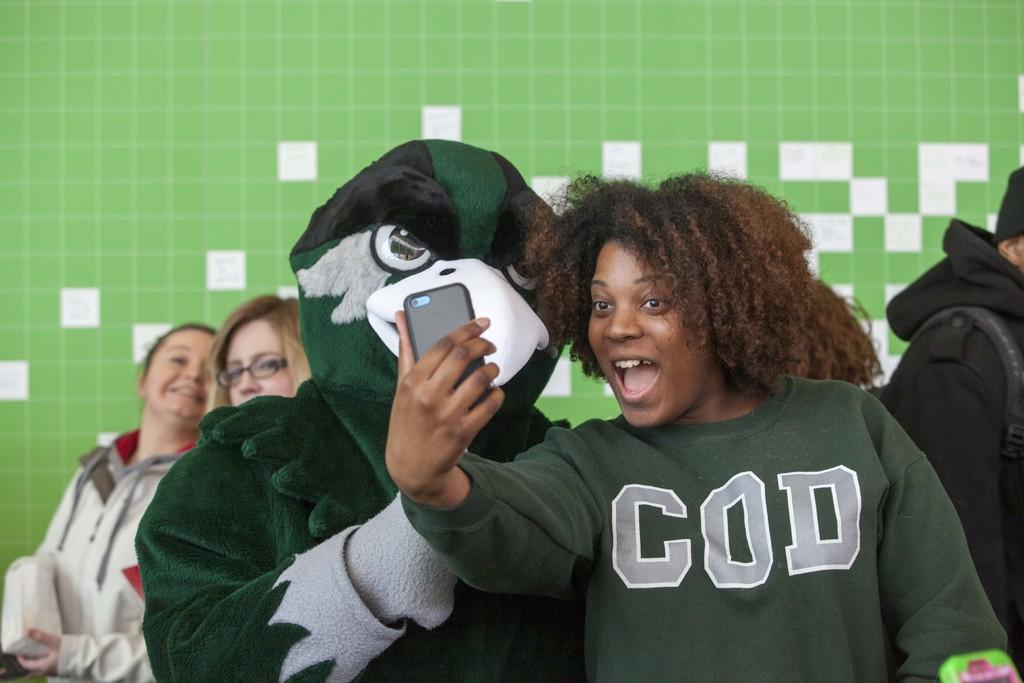Could you give a brief overview of what you see in this image? In this picture we can see a person standing beside to a person wearing fancy dress and taking a snap. On the background we can see persons. 